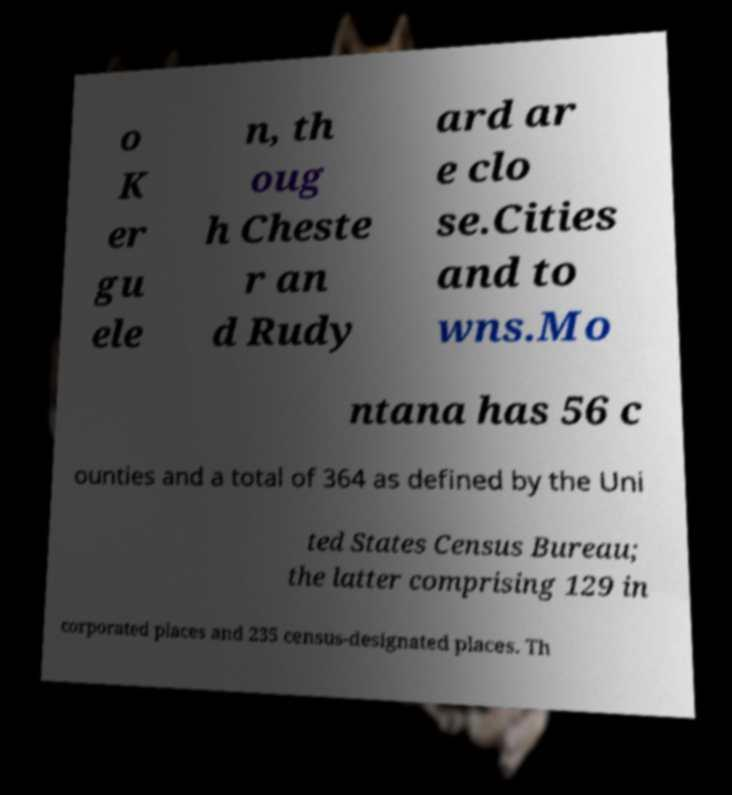Please read and relay the text visible in this image. What does it say? o K er gu ele n, th oug h Cheste r an d Rudy ard ar e clo se.Cities and to wns.Mo ntana has 56 c ounties and a total of 364 as defined by the Uni ted States Census Bureau; the latter comprising 129 in corporated places and 235 census-designated places. Th 